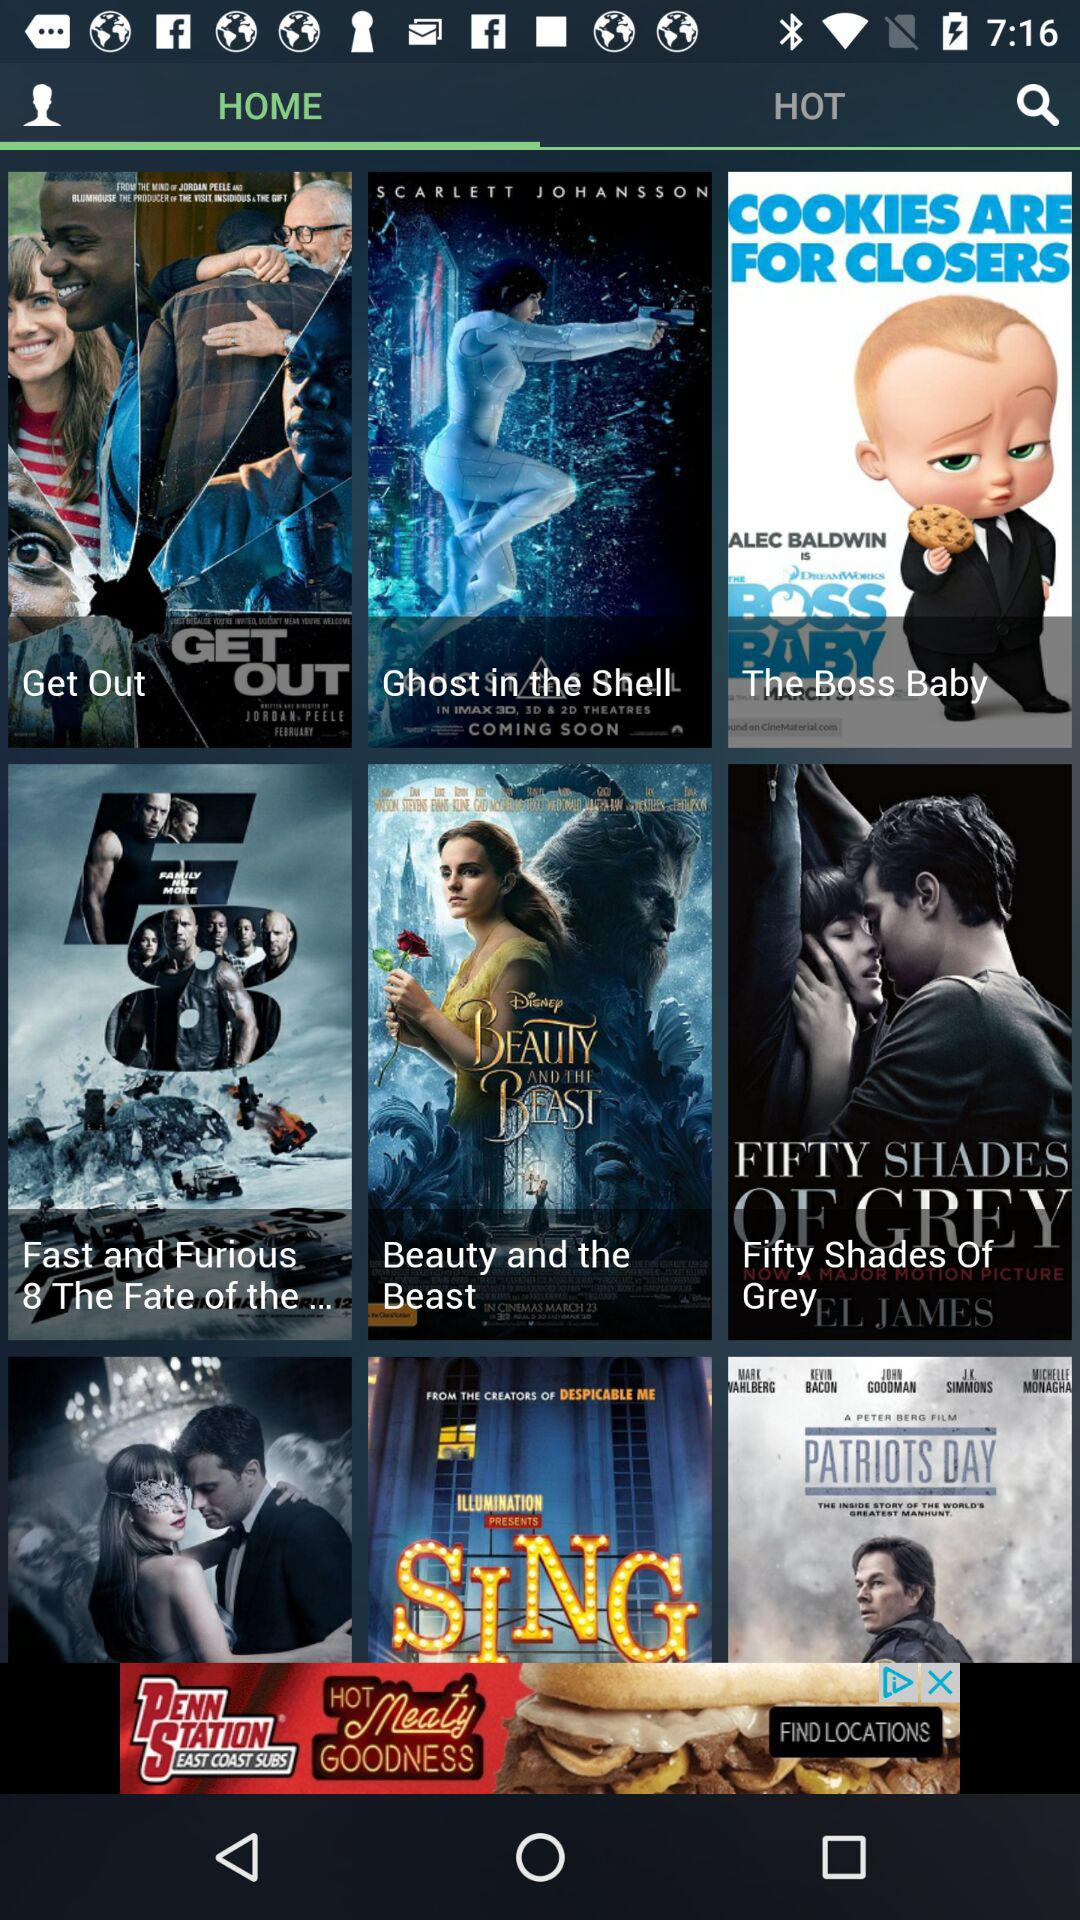What tab is selected? The selected tab is "HOME". 